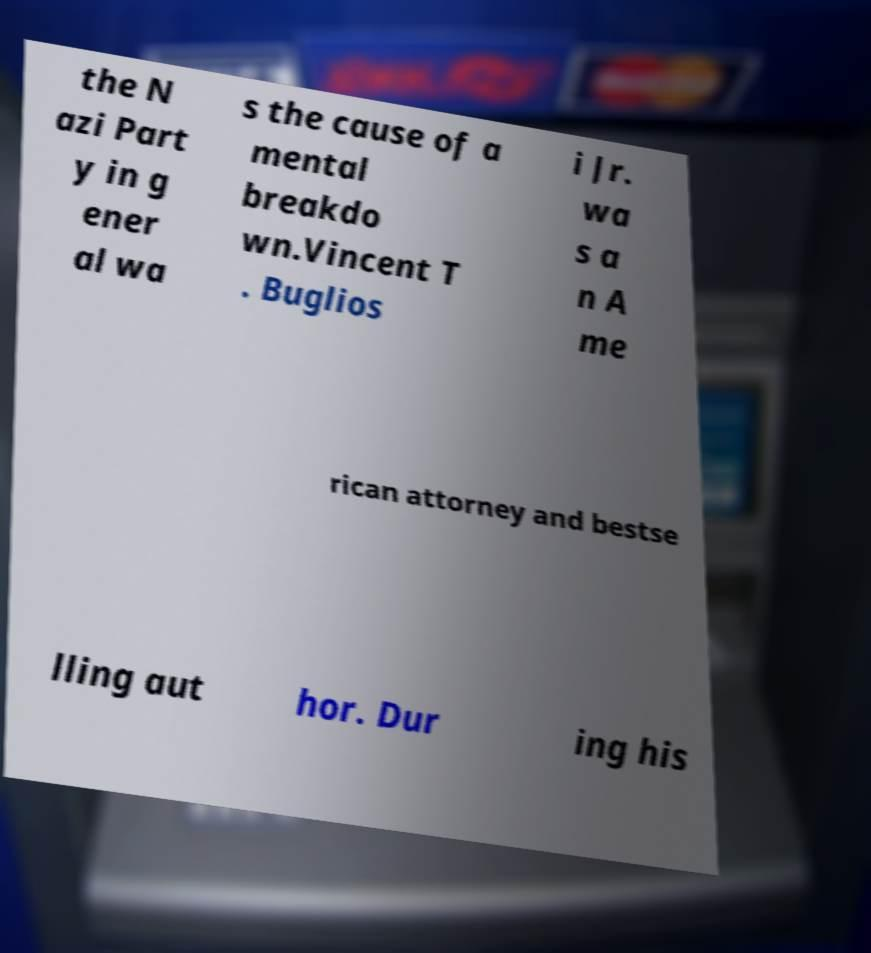For documentation purposes, I need the text within this image transcribed. Could you provide that? the N azi Part y in g ener al wa s the cause of a mental breakdo wn.Vincent T . Buglios i Jr. wa s a n A me rican attorney and bestse lling aut hor. Dur ing his 